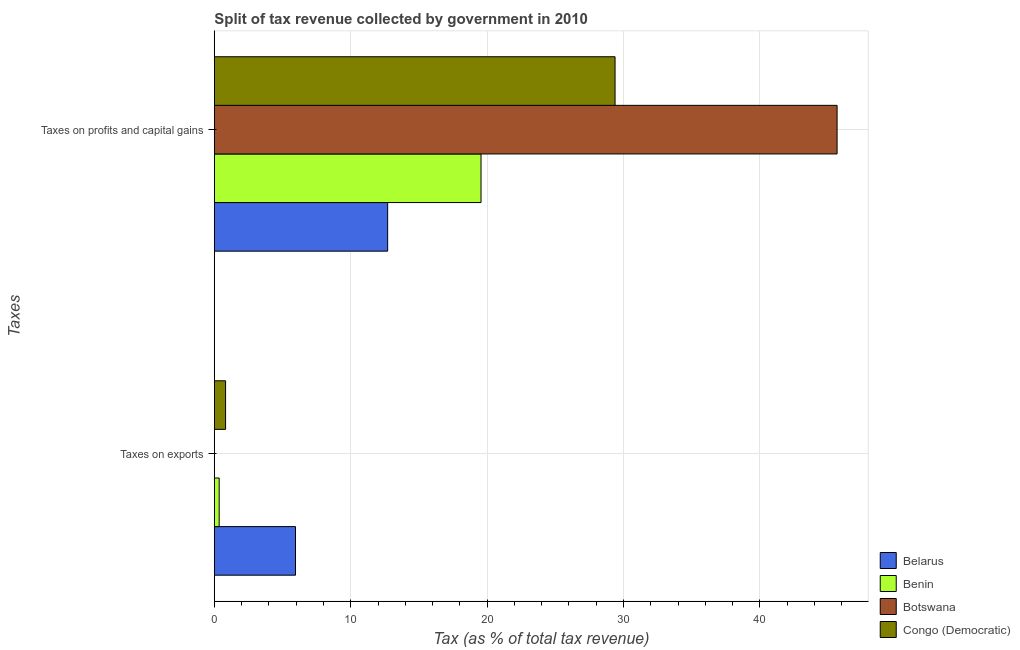What is the label of the 2nd group of bars from the top?
Give a very brief answer. Taxes on exports. What is the percentage of revenue obtained from taxes on exports in Botswana?
Your response must be concise. 0.01. Across all countries, what is the maximum percentage of revenue obtained from taxes on exports?
Give a very brief answer. 5.95. Across all countries, what is the minimum percentage of revenue obtained from taxes on exports?
Your answer should be very brief. 0.01. In which country was the percentage of revenue obtained from taxes on profits and capital gains maximum?
Offer a terse response. Botswana. In which country was the percentage of revenue obtained from taxes on exports minimum?
Give a very brief answer. Botswana. What is the total percentage of revenue obtained from taxes on profits and capital gains in the graph?
Provide a short and direct response. 107.3. What is the difference between the percentage of revenue obtained from taxes on exports in Congo (Democratic) and that in Belarus?
Offer a very short reply. -5.13. What is the difference between the percentage of revenue obtained from taxes on profits and capital gains in Congo (Democratic) and the percentage of revenue obtained from taxes on exports in Benin?
Your response must be concise. 29.03. What is the average percentage of revenue obtained from taxes on exports per country?
Provide a succinct answer. 1.78. What is the difference between the percentage of revenue obtained from taxes on profits and capital gains and percentage of revenue obtained from taxes on exports in Botswana?
Ensure brevity in your answer.  45.65. What is the ratio of the percentage of revenue obtained from taxes on exports in Benin to that in Belarus?
Provide a short and direct response. 0.06. Is the percentage of revenue obtained from taxes on profits and capital gains in Botswana less than that in Belarus?
Make the answer very short. No. In how many countries, is the percentage of revenue obtained from taxes on exports greater than the average percentage of revenue obtained from taxes on exports taken over all countries?
Provide a succinct answer. 1. What does the 4th bar from the top in Taxes on profits and capital gains represents?
Keep it short and to the point. Belarus. What does the 4th bar from the bottom in Taxes on profits and capital gains represents?
Offer a terse response. Congo (Democratic). How many bars are there?
Provide a succinct answer. 8. Are all the bars in the graph horizontal?
Your response must be concise. Yes. What is the difference between two consecutive major ticks on the X-axis?
Ensure brevity in your answer.  10. Are the values on the major ticks of X-axis written in scientific E-notation?
Offer a very short reply. No. Does the graph contain any zero values?
Keep it short and to the point. No. Does the graph contain grids?
Ensure brevity in your answer.  Yes. How many legend labels are there?
Your answer should be compact. 4. What is the title of the graph?
Ensure brevity in your answer.  Split of tax revenue collected by government in 2010. What is the label or title of the X-axis?
Provide a succinct answer. Tax (as % of total tax revenue). What is the label or title of the Y-axis?
Give a very brief answer. Taxes. What is the Tax (as % of total tax revenue) in Belarus in Taxes on exports?
Your answer should be very brief. 5.95. What is the Tax (as % of total tax revenue) of Benin in Taxes on exports?
Offer a very short reply. 0.35. What is the Tax (as % of total tax revenue) in Botswana in Taxes on exports?
Your response must be concise. 0.01. What is the Tax (as % of total tax revenue) in Congo (Democratic) in Taxes on exports?
Offer a very short reply. 0.82. What is the Tax (as % of total tax revenue) in Belarus in Taxes on profits and capital gains?
Offer a very short reply. 12.71. What is the Tax (as % of total tax revenue) of Benin in Taxes on profits and capital gains?
Offer a very short reply. 19.55. What is the Tax (as % of total tax revenue) in Botswana in Taxes on profits and capital gains?
Give a very brief answer. 45.66. What is the Tax (as % of total tax revenue) of Congo (Democratic) in Taxes on profits and capital gains?
Keep it short and to the point. 29.38. Across all Taxes, what is the maximum Tax (as % of total tax revenue) in Belarus?
Offer a terse response. 12.71. Across all Taxes, what is the maximum Tax (as % of total tax revenue) of Benin?
Offer a very short reply. 19.55. Across all Taxes, what is the maximum Tax (as % of total tax revenue) of Botswana?
Ensure brevity in your answer.  45.66. Across all Taxes, what is the maximum Tax (as % of total tax revenue) in Congo (Democratic)?
Your answer should be compact. 29.38. Across all Taxes, what is the minimum Tax (as % of total tax revenue) of Belarus?
Your answer should be very brief. 5.95. Across all Taxes, what is the minimum Tax (as % of total tax revenue) in Benin?
Keep it short and to the point. 0.35. Across all Taxes, what is the minimum Tax (as % of total tax revenue) of Botswana?
Give a very brief answer. 0.01. Across all Taxes, what is the minimum Tax (as % of total tax revenue) in Congo (Democratic)?
Provide a short and direct response. 0.82. What is the total Tax (as % of total tax revenue) in Belarus in the graph?
Make the answer very short. 18.66. What is the total Tax (as % of total tax revenue) of Benin in the graph?
Provide a short and direct response. 19.91. What is the total Tax (as % of total tax revenue) in Botswana in the graph?
Provide a succinct answer. 45.67. What is the total Tax (as % of total tax revenue) of Congo (Democratic) in the graph?
Offer a terse response. 30.2. What is the difference between the Tax (as % of total tax revenue) of Belarus in Taxes on exports and that in Taxes on profits and capital gains?
Provide a short and direct response. -6.76. What is the difference between the Tax (as % of total tax revenue) of Benin in Taxes on exports and that in Taxes on profits and capital gains?
Give a very brief answer. -19.2. What is the difference between the Tax (as % of total tax revenue) in Botswana in Taxes on exports and that in Taxes on profits and capital gains?
Make the answer very short. -45.65. What is the difference between the Tax (as % of total tax revenue) of Congo (Democratic) in Taxes on exports and that in Taxes on profits and capital gains?
Your answer should be very brief. -28.56. What is the difference between the Tax (as % of total tax revenue) in Belarus in Taxes on exports and the Tax (as % of total tax revenue) in Benin in Taxes on profits and capital gains?
Provide a succinct answer. -13.6. What is the difference between the Tax (as % of total tax revenue) of Belarus in Taxes on exports and the Tax (as % of total tax revenue) of Botswana in Taxes on profits and capital gains?
Offer a very short reply. -39.71. What is the difference between the Tax (as % of total tax revenue) in Belarus in Taxes on exports and the Tax (as % of total tax revenue) in Congo (Democratic) in Taxes on profits and capital gains?
Keep it short and to the point. -23.43. What is the difference between the Tax (as % of total tax revenue) of Benin in Taxes on exports and the Tax (as % of total tax revenue) of Botswana in Taxes on profits and capital gains?
Provide a succinct answer. -45.31. What is the difference between the Tax (as % of total tax revenue) in Benin in Taxes on exports and the Tax (as % of total tax revenue) in Congo (Democratic) in Taxes on profits and capital gains?
Your answer should be compact. -29.03. What is the difference between the Tax (as % of total tax revenue) in Botswana in Taxes on exports and the Tax (as % of total tax revenue) in Congo (Democratic) in Taxes on profits and capital gains?
Make the answer very short. -29.37. What is the average Tax (as % of total tax revenue) of Belarus per Taxes?
Give a very brief answer. 9.33. What is the average Tax (as % of total tax revenue) of Benin per Taxes?
Your answer should be compact. 9.95. What is the average Tax (as % of total tax revenue) in Botswana per Taxes?
Your answer should be very brief. 22.83. What is the average Tax (as % of total tax revenue) of Congo (Democratic) per Taxes?
Your answer should be compact. 15.1. What is the difference between the Tax (as % of total tax revenue) of Belarus and Tax (as % of total tax revenue) of Benin in Taxes on exports?
Provide a succinct answer. 5.6. What is the difference between the Tax (as % of total tax revenue) in Belarus and Tax (as % of total tax revenue) in Botswana in Taxes on exports?
Your answer should be compact. 5.94. What is the difference between the Tax (as % of total tax revenue) in Belarus and Tax (as % of total tax revenue) in Congo (Democratic) in Taxes on exports?
Provide a short and direct response. 5.13. What is the difference between the Tax (as % of total tax revenue) of Benin and Tax (as % of total tax revenue) of Botswana in Taxes on exports?
Offer a terse response. 0.35. What is the difference between the Tax (as % of total tax revenue) in Benin and Tax (as % of total tax revenue) in Congo (Democratic) in Taxes on exports?
Your response must be concise. -0.47. What is the difference between the Tax (as % of total tax revenue) of Botswana and Tax (as % of total tax revenue) of Congo (Democratic) in Taxes on exports?
Ensure brevity in your answer.  -0.82. What is the difference between the Tax (as % of total tax revenue) of Belarus and Tax (as % of total tax revenue) of Benin in Taxes on profits and capital gains?
Make the answer very short. -6.84. What is the difference between the Tax (as % of total tax revenue) in Belarus and Tax (as % of total tax revenue) in Botswana in Taxes on profits and capital gains?
Provide a short and direct response. -32.95. What is the difference between the Tax (as % of total tax revenue) in Belarus and Tax (as % of total tax revenue) in Congo (Democratic) in Taxes on profits and capital gains?
Give a very brief answer. -16.67. What is the difference between the Tax (as % of total tax revenue) of Benin and Tax (as % of total tax revenue) of Botswana in Taxes on profits and capital gains?
Make the answer very short. -26.11. What is the difference between the Tax (as % of total tax revenue) of Benin and Tax (as % of total tax revenue) of Congo (Democratic) in Taxes on profits and capital gains?
Make the answer very short. -9.83. What is the difference between the Tax (as % of total tax revenue) of Botswana and Tax (as % of total tax revenue) of Congo (Democratic) in Taxes on profits and capital gains?
Keep it short and to the point. 16.28. What is the ratio of the Tax (as % of total tax revenue) of Belarus in Taxes on exports to that in Taxes on profits and capital gains?
Give a very brief answer. 0.47. What is the ratio of the Tax (as % of total tax revenue) of Benin in Taxes on exports to that in Taxes on profits and capital gains?
Give a very brief answer. 0.02. What is the ratio of the Tax (as % of total tax revenue) in Congo (Democratic) in Taxes on exports to that in Taxes on profits and capital gains?
Give a very brief answer. 0.03. What is the difference between the highest and the second highest Tax (as % of total tax revenue) in Belarus?
Provide a short and direct response. 6.76. What is the difference between the highest and the second highest Tax (as % of total tax revenue) of Benin?
Your response must be concise. 19.2. What is the difference between the highest and the second highest Tax (as % of total tax revenue) of Botswana?
Your answer should be very brief. 45.65. What is the difference between the highest and the second highest Tax (as % of total tax revenue) of Congo (Democratic)?
Keep it short and to the point. 28.56. What is the difference between the highest and the lowest Tax (as % of total tax revenue) of Belarus?
Provide a short and direct response. 6.76. What is the difference between the highest and the lowest Tax (as % of total tax revenue) of Benin?
Offer a terse response. 19.2. What is the difference between the highest and the lowest Tax (as % of total tax revenue) of Botswana?
Make the answer very short. 45.65. What is the difference between the highest and the lowest Tax (as % of total tax revenue) in Congo (Democratic)?
Ensure brevity in your answer.  28.56. 